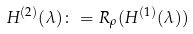Convert formula to latex. <formula><loc_0><loc_0><loc_500><loc_500>H ^ { ( 2 ) } ( \lambda ) \colon = R _ { \rho } ( H ^ { ( 1 ) } ( \lambda ) )</formula> 